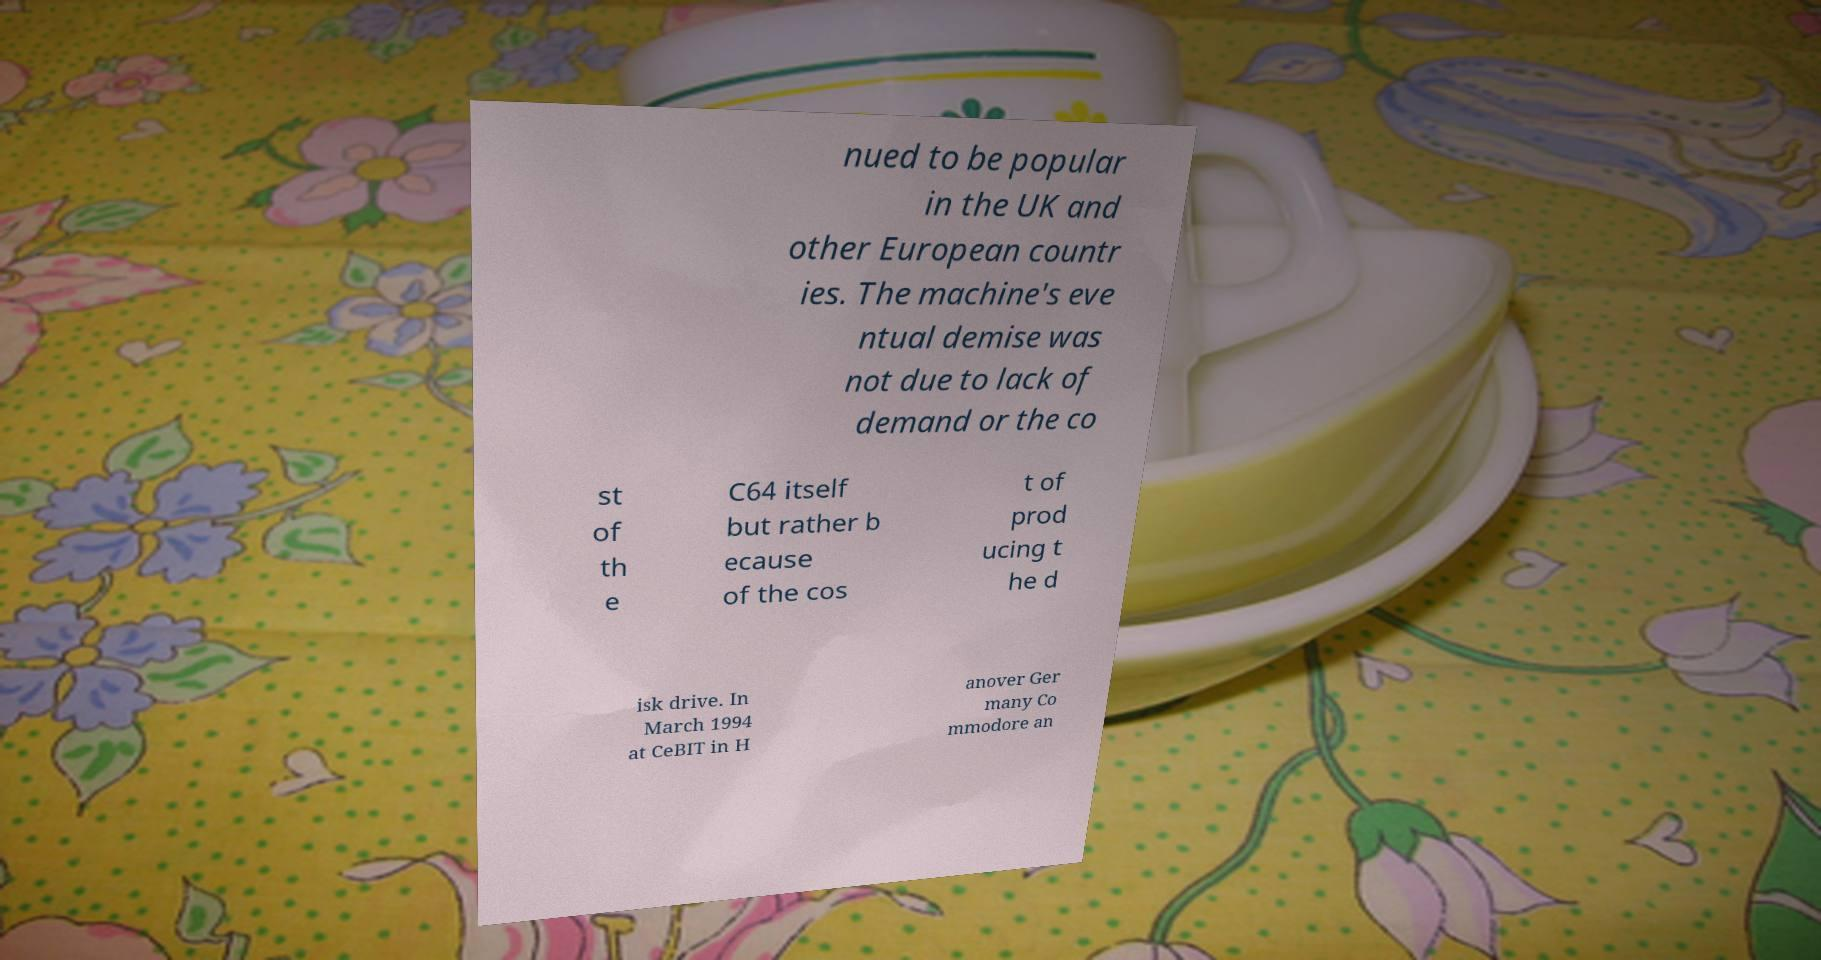Can you read and provide the text displayed in the image?This photo seems to have some interesting text. Can you extract and type it out for me? nued to be popular in the UK and other European countr ies. The machine's eve ntual demise was not due to lack of demand or the co st of th e C64 itself but rather b ecause of the cos t of prod ucing t he d isk drive. In March 1994 at CeBIT in H anover Ger many Co mmodore an 